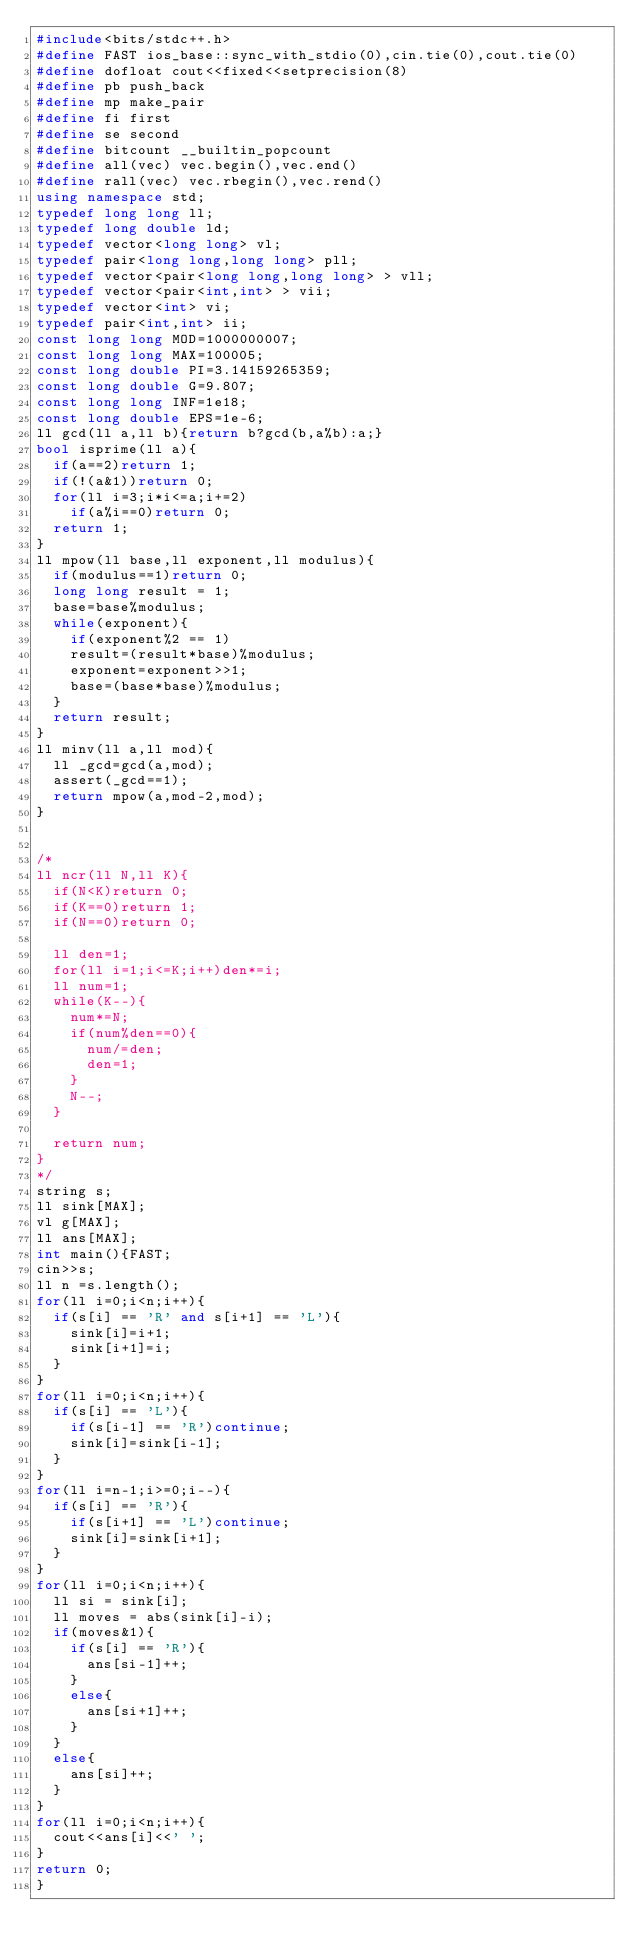<code> <loc_0><loc_0><loc_500><loc_500><_C++_>#include<bits/stdc++.h>
#define FAST ios_base::sync_with_stdio(0),cin.tie(0),cout.tie(0)
#define dofloat cout<<fixed<<setprecision(8)
#define pb push_back
#define mp make_pair
#define fi first
#define se second
#define bitcount __builtin_popcount
#define all(vec) vec.begin(),vec.end()
#define rall(vec) vec.rbegin(),vec.rend()
using namespace std;
typedef long long ll;
typedef long double ld;
typedef vector<long long> vl;
typedef pair<long long,long long> pll;
typedef vector<pair<long long,long long> > vll;
typedef vector<pair<int,int> > vii;
typedef vector<int> vi;
typedef pair<int,int> ii;
const long long MOD=1000000007;
const long long MAX=100005;
const long double PI=3.14159265359;
const long double G=9.807;
const long long INF=1e18;
const long double EPS=1e-6;
ll gcd(ll a,ll b){return b?gcd(b,a%b):a;}
bool isprime(ll a){
  if(a==2)return 1;
  if(!(a&1))return 0;
  for(ll i=3;i*i<=a;i+=2)
    if(a%i==0)return 0;
  return 1;
}
ll mpow(ll base,ll exponent,ll modulus){
  if(modulus==1)return 0;
  long long result = 1;
  base=base%modulus;
  while(exponent){
    if(exponent%2 == 1)
	  result=(result*base)%modulus;
	  exponent=exponent>>1;
	  base=(base*base)%modulus;
  }
  return result;
}
ll minv(ll a,ll mod){
  ll _gcd=gcd(a,mod);
  assert(_gcd==1);
  return mpow(a,mod-2,mod);
}


/*
ll ncr(ll N,ll K){
	if(N<K)return 0;
	if(K==0)return 1;
	if(N==0)return 0;

	ll den=1;
	for(ll i=1;i<=K;i++)den*=i;
	ll num=1;
	while(K--){
		num*=N;
		if(num%den==0){
			num/=den;
			den=1;
		}
		N--;
	}

	return num;
}
*/
string s;
ll sink[MAX];
vl g[MAX];
ll ans[MAX];
int main(){FAST;
cin>>s;
ll n =s.length();
for(ll i=0;i<n;i++){
	if(s[i] == 'R' and s[i+1] == 'L'){
		sink[i]=i+1;
		sink[i+1]=i;
	}
}
for(ll i=0;i<n;i++){
	if(s[i] == 'L'){
		if(s[i-1] == 'R')continue;
		sink[i]=sink[i-1];
	}
}
for(ll i=n-1;i>=0;i--){
	if(s[i] == 'R'){
		if(s[i+1] == 'L')continue;
		sink[i]=sink[i+1];
	}
}
for(ll i=0;i<n;i++){
	ll si = sink[i];
	ll moves = abs(sink[i]-i);
	if(moves&1){
		if(s[i] == 'R'){
			ans[si-1]++;
		}
		else{
			ans[si+1]++;
		}
	}
	else{
		ans[si]++;	
	}
}
for(ll i=0;i<n;i++){
	cout<<ans[i]<<' ';
}
return 0;
}</code> 